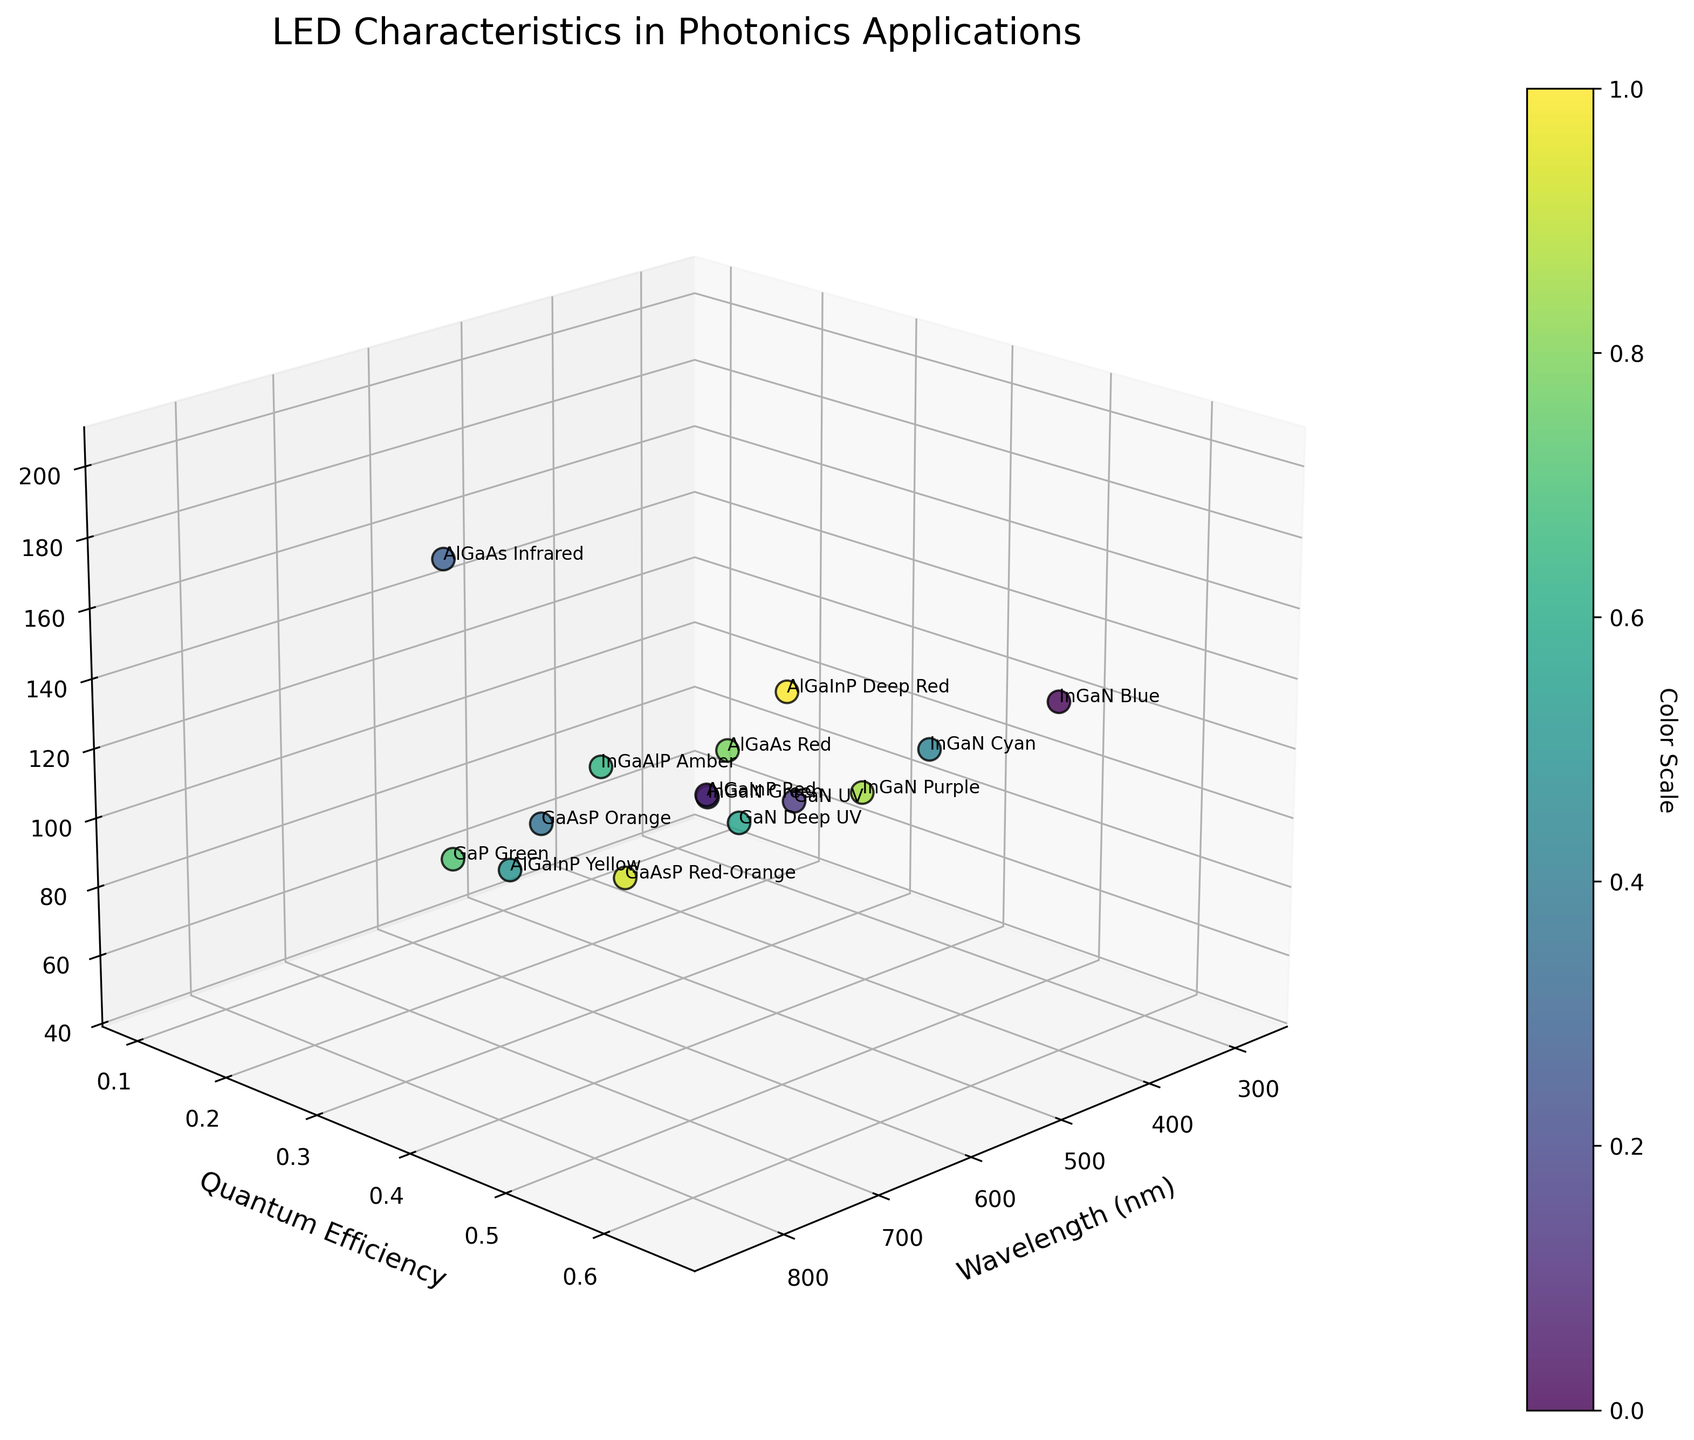What is the title of the figure? The title of the figure is usually found at the top of the plot. In this case, it is clearly written above the plot.
Answer: LED Characteristics in Photonics Applications What does the x-axis represent? The axis labels can be found adjacent to the respective axes. Here, the x-axis label is "Wavelength (nm)".
Answer: Wavelength (nm) Which LED type has the highest Quantum Efficiency? By identifying the highest point along the y-axis (Quantum Efficiency), we can then check the label for that point. The label corresponds to the "InGaN Blue" with a Quantum Efficiency of 0.65.
Answer: InGaN Blue Which LED type produces the lowest power output? Look for the lowest point on the z-axis (Power Output), find the corresponding data label, which is "GaN Deep UV" at 50 mW.
Answer: GaN Deep UV What is the Quantum Efficiency for the InGaN Cyan LED? Locate the "InGaN Cyan" label in the plot and check its position along the y-axis. The Quantum Efficiency for InGaN Cyan is marked at 0.55.
Answer: 0.55 How many LEDs have a power output greater than 100 mW? Count the number of data points (LEDs) positioned above the 100 mW mark along the z-axis. There are six such LEDs.
Answer: 6 Which LED type has the longest wavelength? Identify the farthest point along the x-axis (Wavelength in nm), and check the label for that data point. The LED with the longest wavelength is "AlGaAs Infrared" at 850 nm.
Answer: AlGaAs Infrared Compare the quantum efficiency of AlGaInP Red and AlGaInP Yellow. Which one is higher? Locate the "AlGaInP Red" and "AlGaInP Yellow" labels, compare their heights along the y-axis. AlGaInP Red has a Quantum Efficiency of 0.45, whereas AlGaInP Yellow has 0.20. AlGaInP Red is higher.
Answer: AlGaInP Red What is the average Quantum Efficiency of the InGaN family (Blue, Green, Cyan, Purple)? Sum the Quantum Efficiency values for InGaN Blue (0.65), InGaN Green (0.35), InGaN Cyan (0.55), and InGaN Purple (0.40), then divide by 4. (0.65 + 0.35 + 0.55 + 0.40) / 4 = 1.95 / 4 = 0.4875
Answer: 0.4875 